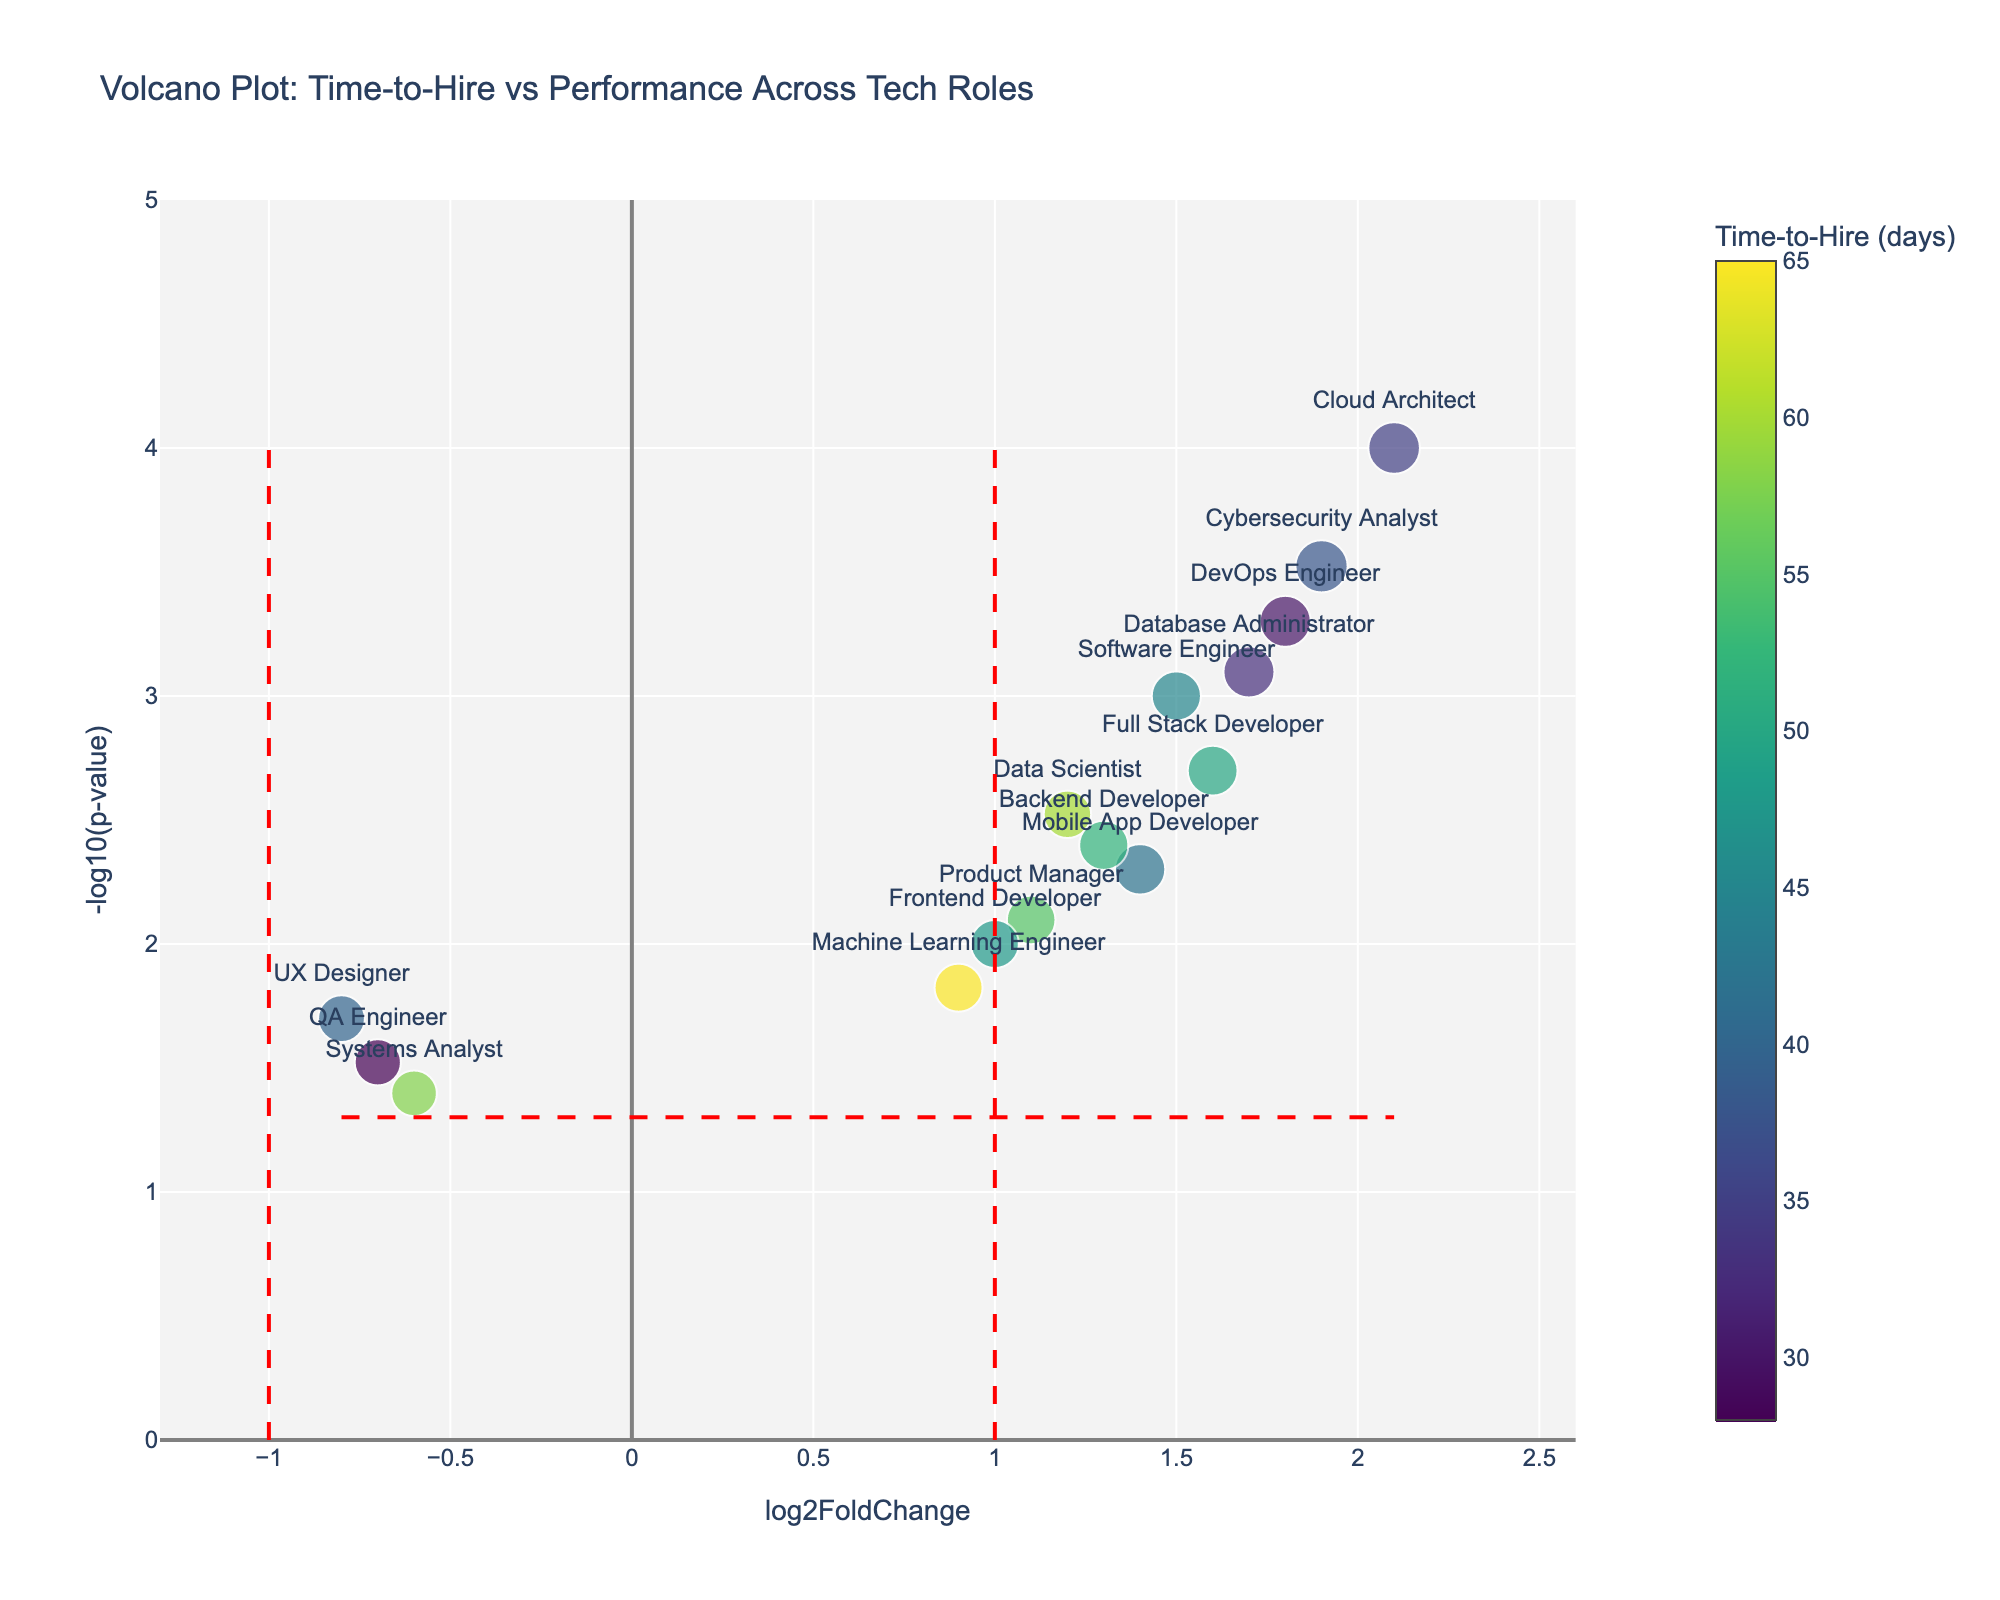What is the title of the figure? The title is usually displayed at the top of the figure in a prominent font. Here, it is specified to be 'Volcano Plot: Time-to-Hire vs Performance Across Tech Roles'.
Answer: 'Volcano Plot: Time-to-Hire vs Performance Across Tech Roles' What is on the x-axis of the figure? The x-axis is labeled as 'log2FoldChange', which is a standard measure in volcano plots for the ratio of change in two conditions.
Answer: log2FoldChange What is the significance threshold in the figure? The significance threshold is determined by -log10(p-value) where the p-value is 0.05. Evaluating -log10(0.05) provides the threshold.
Answer: 1.3 Which role has the highest Performance Score? The Performance Scores are reflected in the size of the markers. The role with the largest marker should have the highest score. The Cybersecurity Analyst has a score of 8.7, which is the highest.
Answer: Cybersecurity Analyst What color palette is used to indicate Time-to-Hire (days)? The color palette for Time-to-Hire is explained as 'Viridis', and roles with lower Time-to-Hire days are denoted with darker colors while those with higher values are displayed in brighter colors.
Answer: Viridis Which role took the least days to hire? Review the color bar scale and marker colors. Darker colors represent fewer days. The QA Engineer marker, with dark color corresponding to 28 days, represents the shortest Time-to-Hire.
Answer: QA Engineer What is the log2FoldChange and -log10(p-value) for the Cloud Architect role? Using the hover or label positioned at the marker for Cloud Architect, the log2FoldChange is 2.1 and -log10(p-value) is -log10(0.0001).
Answer: 2.1 and 4 How many roles have a negative log2FoldChange value? A quick count of markers on the left of the x-axis at zero would give the number. Three roles - UX Designer, QA Engineer, and Systems Analyst - have negative values.
Answer: Three Which role appears most significantly different according to the p-value threshold? The smallest p-value will have the largest -log10(p-value). The Cloud Architect has the smallest p-value (0.0001) and therefore is the most significant according to the plot.
Answer: Cloud Architect 